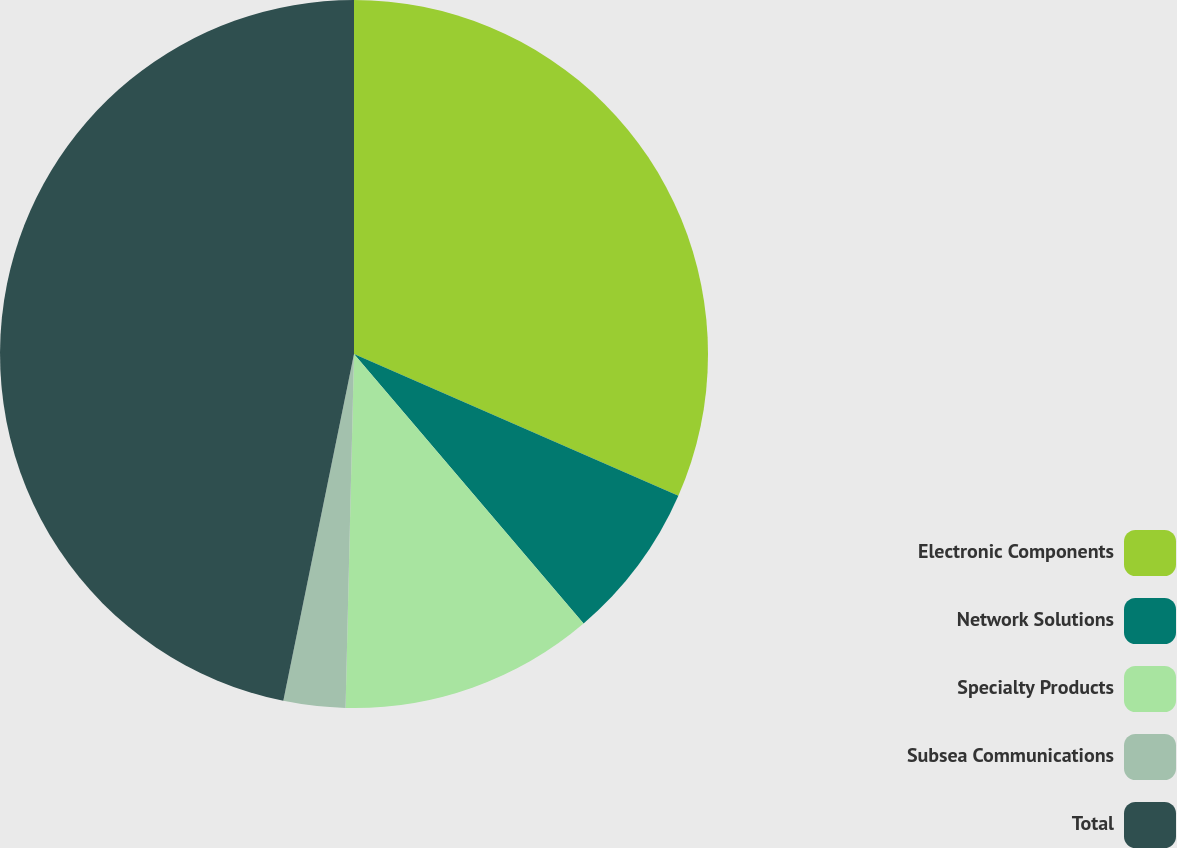Convert chart. <chart><loc_0><loc_0><loc_500><loc_500><pie_chart><fcel>Electronic Components<fcel>Network Solutions<fcel>Specialty Products<fcel>Subsea Communications<fcel>Total<nl><fcel>31.56%<fcel>7.21%<fcel>11.61%<fcel>2.82%<fcel>46.8%<nl></chart> 